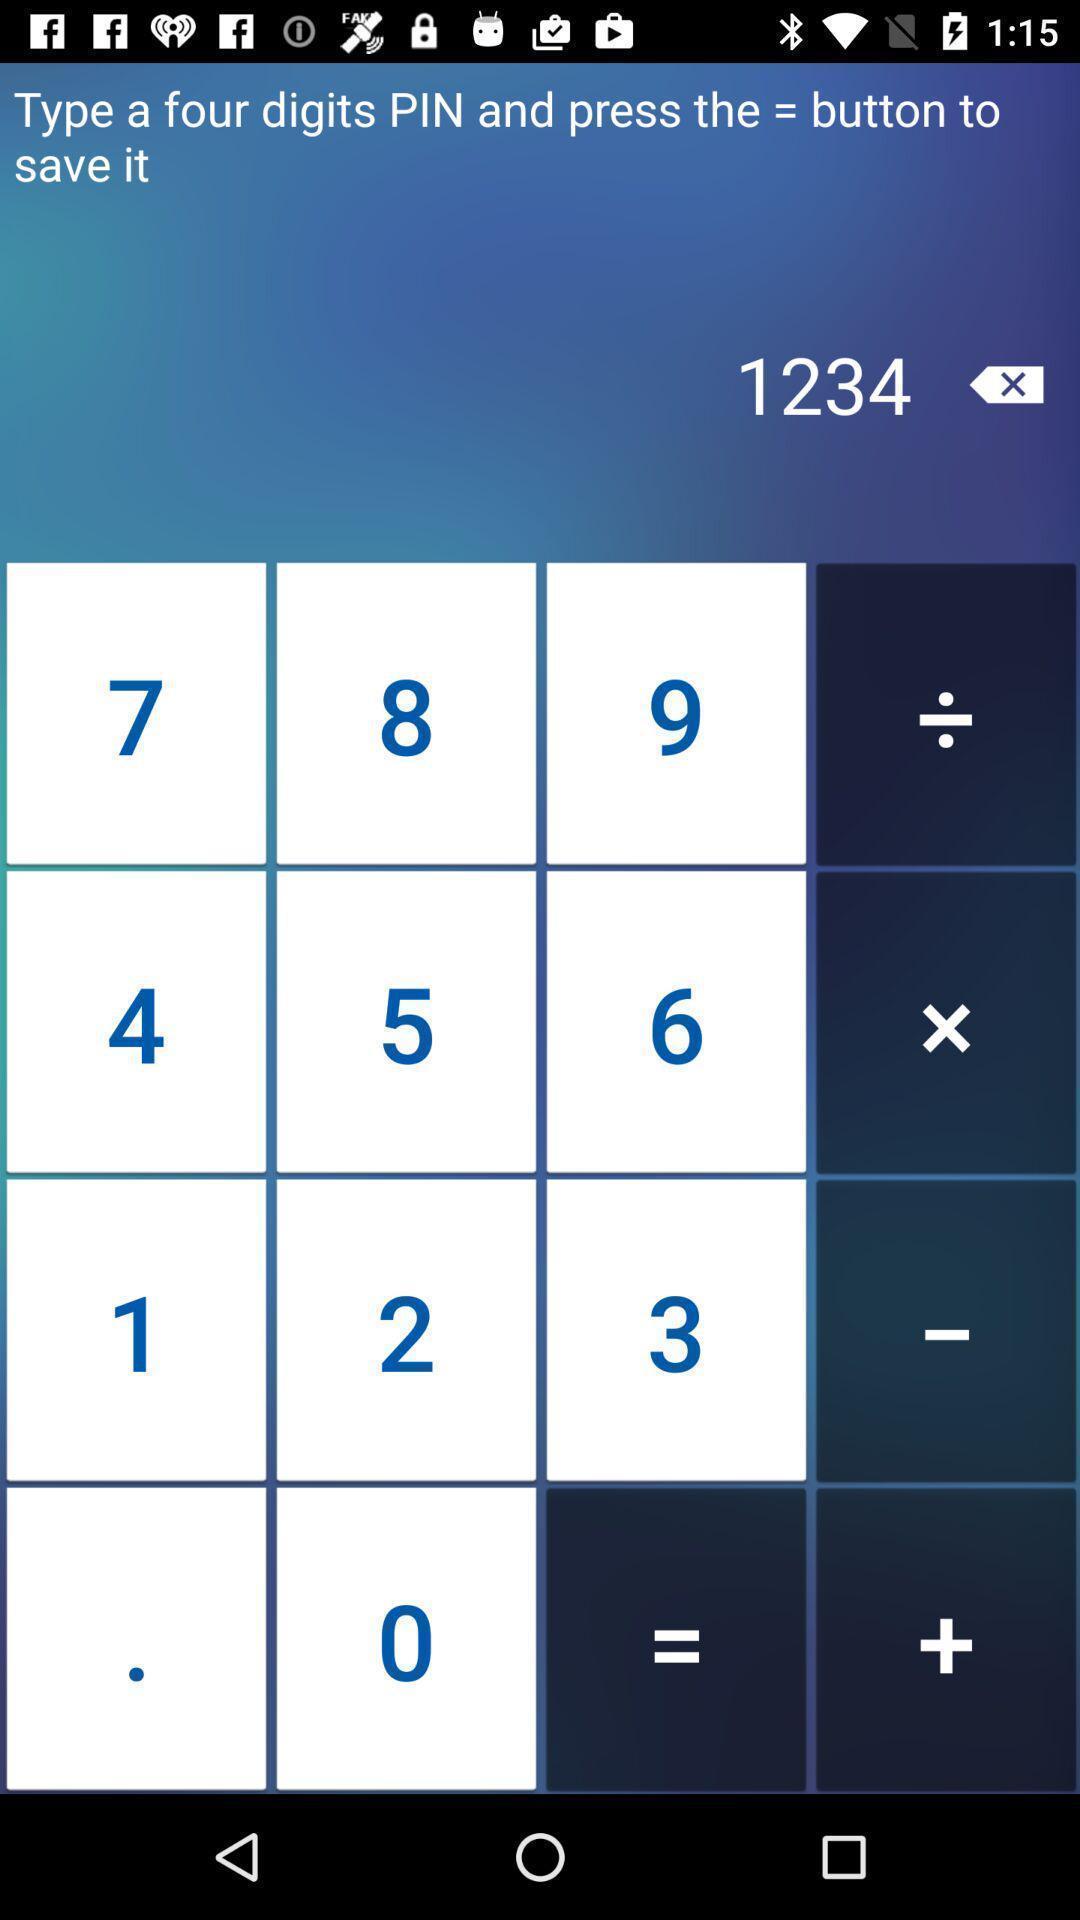Summarize the information in this screenshot. Screen showing a calculation on a device. 